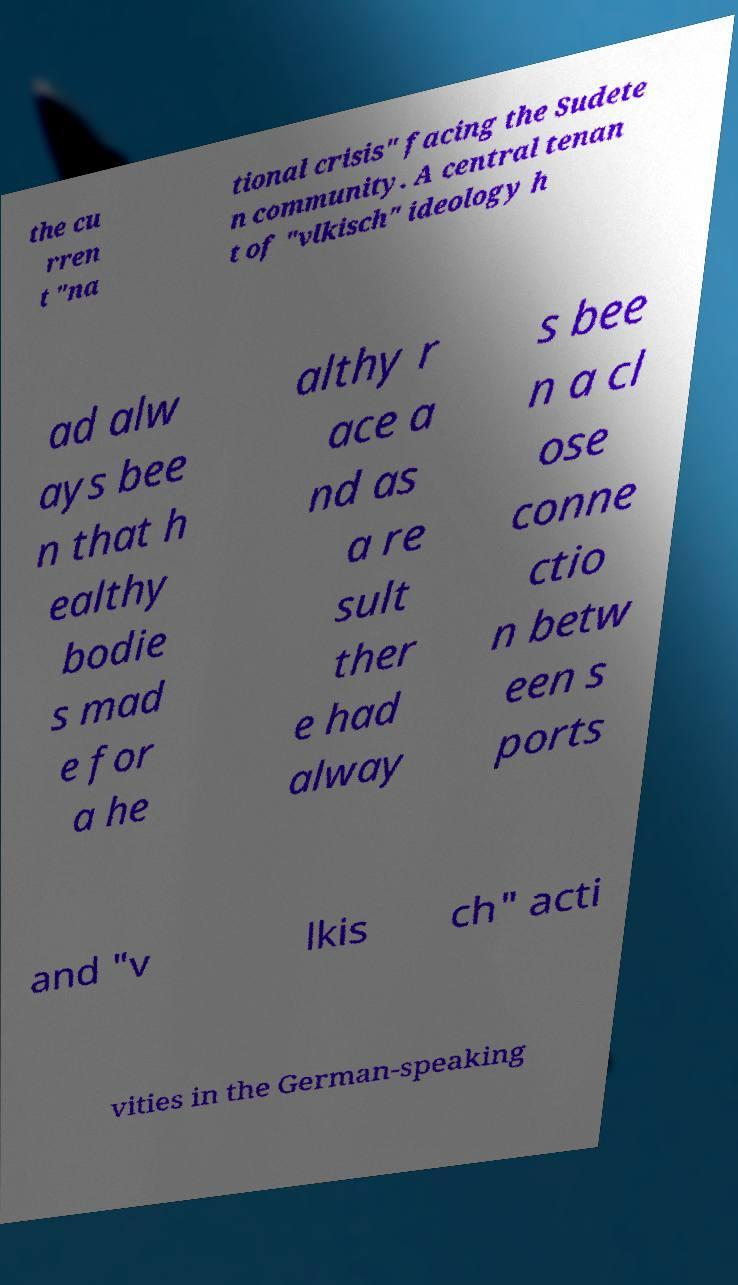Please read and relay the text visible in this image. What does it say? the cu rren t "na tional crisis" facing the Sudete n community. A central tenan t of "vlkisch" ideology h ad alw ays bee n that h ealthy bodie s mad e for a he althy r ace a nd as a re sult ther e had alway s bee n a cl ose conne ctio n betw een s ports and "v lkis ch" acti vities in the German-speaking 